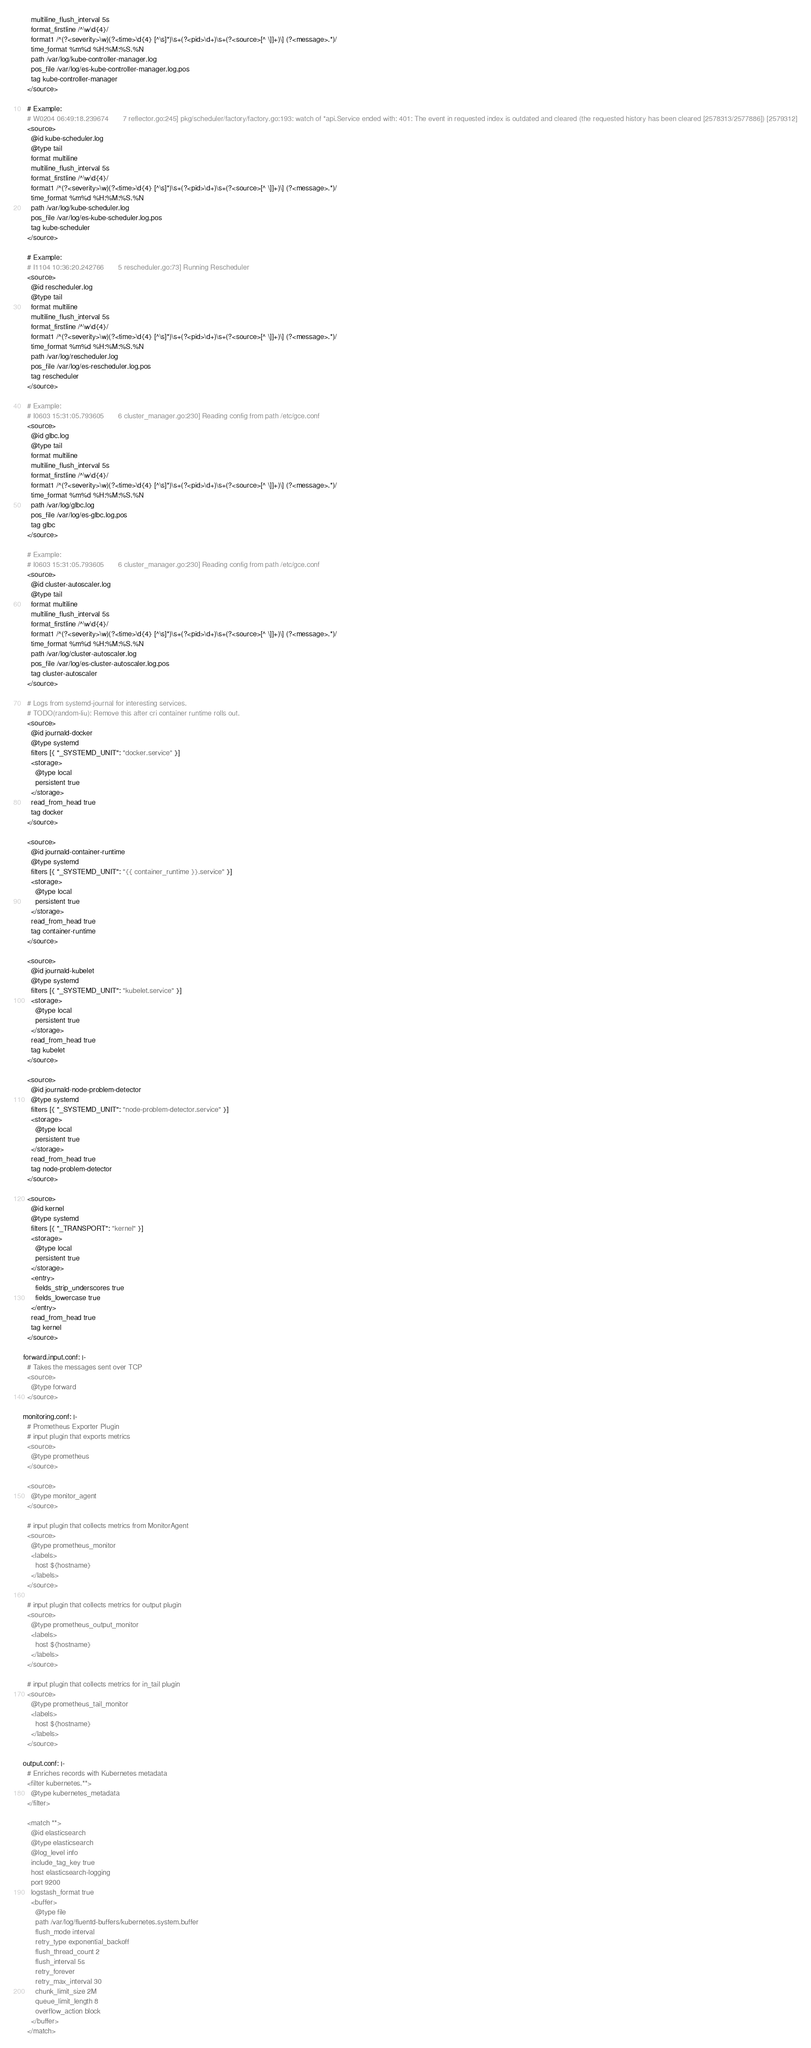<code> <loc_0><loc_0><loc_500><loc_500><_YAML_>      multiline_flush_interval 5s
      format_firstline /^\w\d{4}/
      format1 /^(?<severity>\w)(?<time>\d{4} [^\s]*)\s+(?<pid>\d+)\s+(?<source>[^ \]]+)\] (?<message>.*)/
      time_format %m%d %H:%M:%S.%N
      path /var/log/kube-controller-manager.log
      pos_file /var/log/es-kube-controller-manager.log.pos
      tag kube-controller-manager
    </source>

    # Example:
    # W0204 06:49:18.239674       7 reflector.go:245] pkg/scheduler/factory/factory.go:193: watch of *api.Service ended with: 401: The event in requested index is outdated and cleared (the requested history has been cleared [2578313/2577886]) [2579312]
    <source>
      @id kube-scheduler.log
      @type tail
      format multiline
      multiline_flush_interval 5s
      format_firstline /^\w\d{4}/
      format1 /^(?<severity>\w)(?<time>\d{4} [^\s]*)\s+(?<pid>\d+)\s+(?<source>[^ \]]+)\] (?<message>.*)/
      time_format %m%d %H:%M:%S.%N
      path /var/log/kube-scheduler.log
      pos_file /var/log/es-kube-scheduler.log.pos
      tag kube-scheduler
    </source>

    # Example:
    # I1104 10:36:20.242766       5 rescheduler.go:73] Running Rescheduler
    <source>
      @id rescheduler.log
      @type tail
      format multiline
      multiline_flush_interval 5s
      format_firstline /^\w\d{4}/
      format1 /^(?<severity>\w)(?<time>\d{4} [^\s]*)\s+(?<pid>\d+)\s+(?<source>[^ \]]+)\] (?<message>.*)/
      time_format %m%d %H:%M:%S.%N
      path /var/log/rescheduler.log
      pos_file /var/log/es-rescheduler.log.pos
      tag rescheduler
    </source>

    # Example:
    # I0603 15:31:05.793605       6 cluster_manager.go:230] Reading config from path /etc/gce.conf
    <source>
      @id glbc.log
      @type tail
      format multiline
      multiline_flush_interval 5s
      format_firstline /^\w\d{4}/
      format1 /^(?<severity>\w)(?<time>\d{4} [^\s]*)\s+(?<pid>\d+)\s+(?<source>[^ \]]+)\] (?<message>.*)/
      time_format %m%d %H:%M:%S.%N
      path /var/log/glbc.log
      pos_file /var/log/es-glbc.log.pos
      tag glbc
    </source>

    # Example:
    # I0603 15:31:05.793605       6 cluster_manager.go:230] Reading config from path /etc/gce.conf
    <source>
      @id cluster-autoscaler.log
      @type tail
      format multiline
      multiline_flush_interval 5s
      format_firstline /^\w\d{4}/
      format1 /^(?<severity>\w)(?<time>\d{4} [^\s]*)\s+(?<pid>\d+)\s+(?<source>[^ \]]+)\] (?<message>.*)/
      time_format %m%d %H:%M:%S.%N
      path /var/log/cluster-autoscaler.log
      pos_file /var/log/es-cluster-autoscaler.log.pos
      tag cluster-autoscaler
    </source>

    # Logs from systemd-journal for interesting services.
    # TODO(random-liu): Remove this after cri container runtime rolls out.
    <source>
      @id journald-docker
      @type systemd
      filters [{ "_SYSTEMD_UNIT": "docker.service" }]
      <storage>
        @type local
        persistent true
      </storage>
      read_from_head true
      tag docker
    </source>

    <source>
      @id journald-container-runtime
      @type systemd
      filters [{ "_SYSTEMD_UNIT": "{{ container_runtime }}.service" }]
      <storage>
        @type local
        persistent true
      </storage>
      read_from_head true
      tag container-runtime
    </source>

    <source>
      @id journald-kubelet
      @type systemd
      filters [{ "_SYSTEMD_UNIT": "kubelet.service" }]
      <storage>
        @type local
        persistent true
      </storage>
      read_from_head true
      tag kubelet
    </source>

    <source>
      @id journald-node-problem-detector
      @type systemd
      filters [{ "_SYSTEMD_UNIT": "node-problem-detector.service" }]
      <storage>
        @type local
        persistent true
      </storage>
      read_from_head true
      tag node-problem-detector
    </source>
    
    <source>
      @id kernel
      @type systemd
      filters [{ "_TRANSPORT": "kernel" }]
      <storage>
        @type local
        persistent true
      </storage>
      <entry>
        fields_strip_underscores true
        fields_lowercase true
      </entry>
      read_from_head true
      tag kernel
    </source>

  forward.input.conf: |-
    # Takes the messages sent over TCP
    <source>
      @type forward
    </source>

  monitoring.conf: |-
    # Prometheus Exporter Plugin
    # input plugin that exports metrics
    <source>
      @type prometheus
    </source>

    <source>
      @type monitor_agent
    </source>

    # input plugin that collects metrics from MonitorAgent
    <source>
      @type prometheus_monitor
      <labels>
        host ${hostname}
      </labels>
    </source>

    # input plugin that collects metrics for output plugin
    <source>
      @type prometheus_output_monitor
      <labels>
        host ${hostname}
      </labels>
    </source>

    # input plugin that collects metrics for in_tail plugin
    <source>
      @type prometheus_tail_monitor
      <labels>
        host ${hostname}
      </labels>
    </source>

  output.conf: |-
    # Enriches records with Kubernetes metadata
    <filter kubernetes.**>
      @type kubernetes_metadata
    </filter>

    <match **>
      @id elasticsearch
      @type elasticsearch
      @log_level info
      include_tag_key true
      host elasticsearch-logging
      port 9200
      logstash_format true
      <buffer>
        @type file
        path /var/log/fluentd-buffers/kubernetes.system.buffer
        flush_mode interval
        retry_type exponential_backoff
        flush_thread_count 2
        flush_interval 5s
        retry_forever
        retry_max_interval 30
        chunk_limit_size 2M
        queue_limit_length 8
        overflow_action block
      </buffer>
    </match>
</code> 